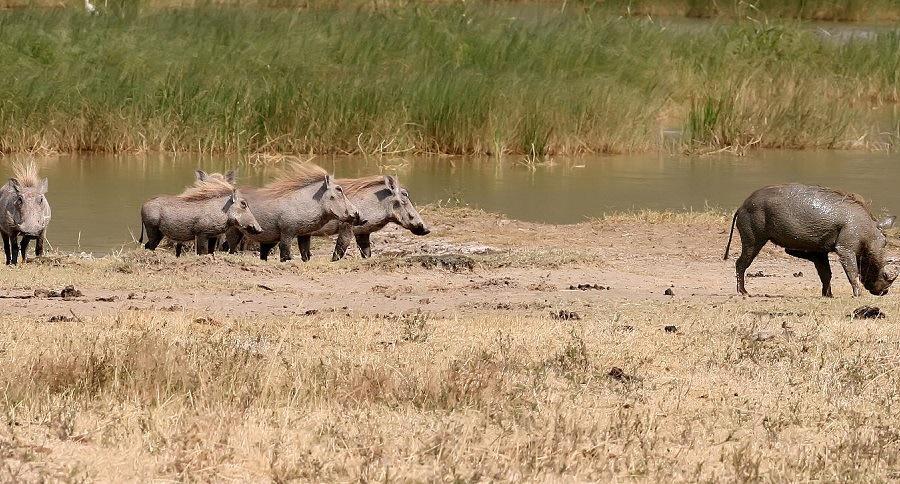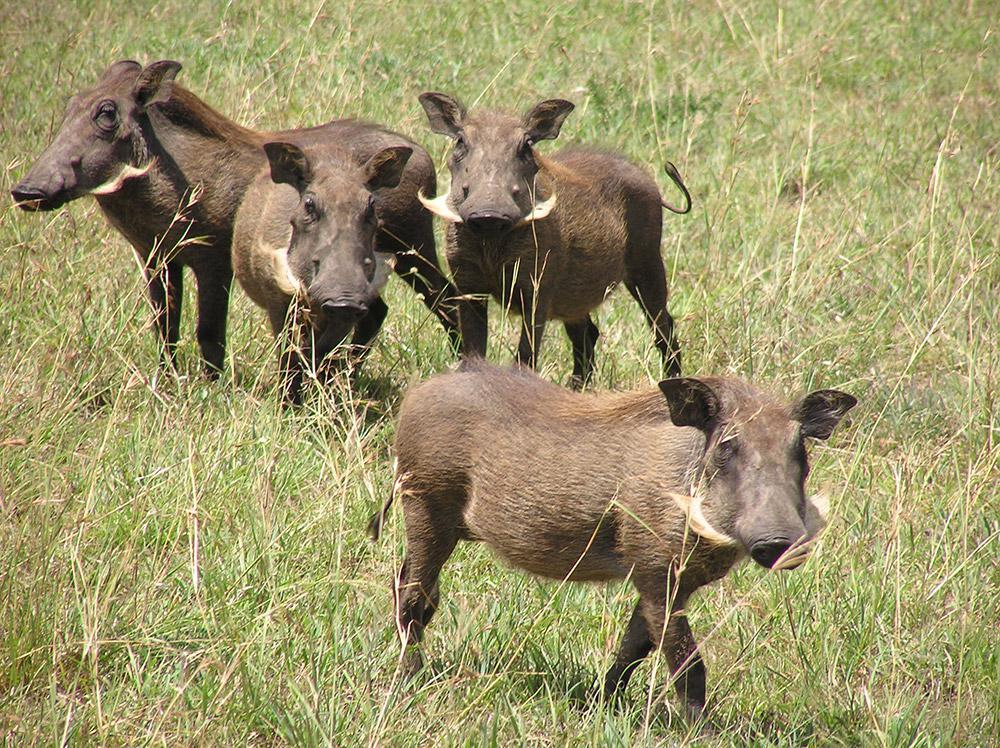The first image is the image on the left, the second image is the image on the right. For the images shown, is this caption "In one of the images there is a group of warthogs standing near water." true? Answer yes or no. Yes. The first image is the image on the left, the second image is the image on the right. Evaluate the accuracy of this statement regarding the images: "There is water in the image on the left.". Is it true? Answer yes or no. Yes. 